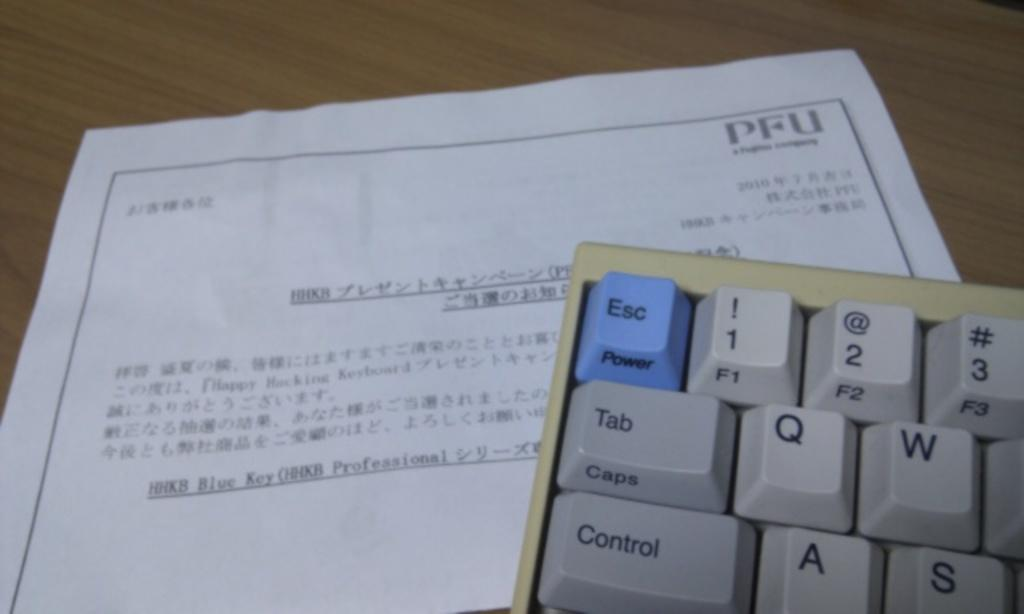<image>
Describe the image concisely. The top left portion of a keyboard on a paper from PFU. 